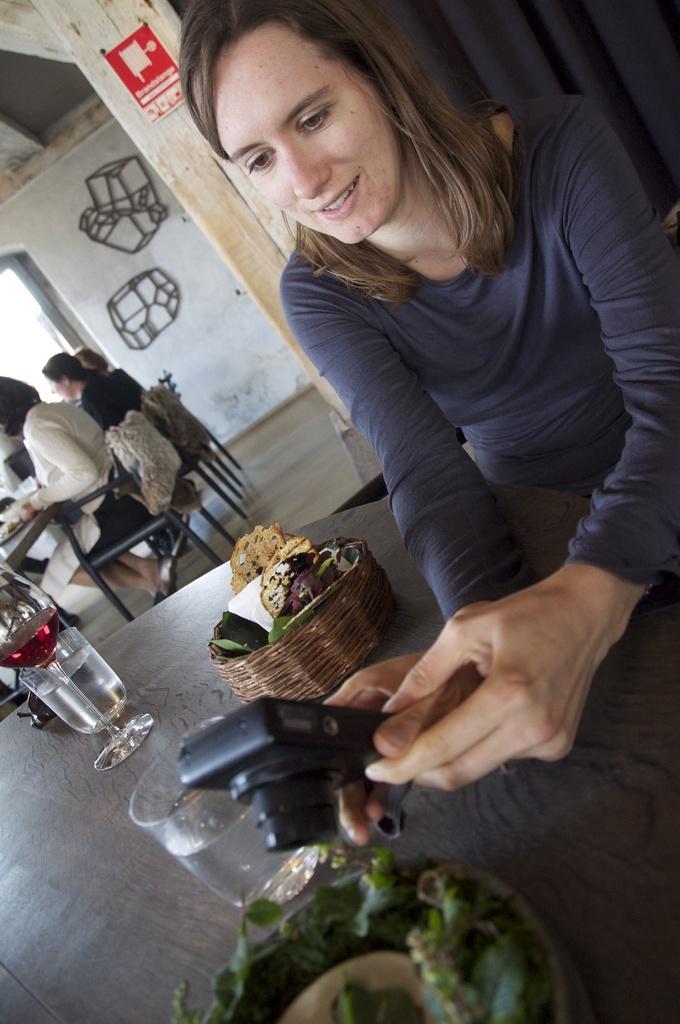How would you summarize this image in a sentence or two? This is the woman sitting and smiling. She is holding a camera. I can see the glasses and the kind of bowls, which are placed on the table. On the left side of the image, I can see few people sitting on the chairs. This looks like a wooden pillar. In the background, I think these are the objects, which are attached to the wall. 